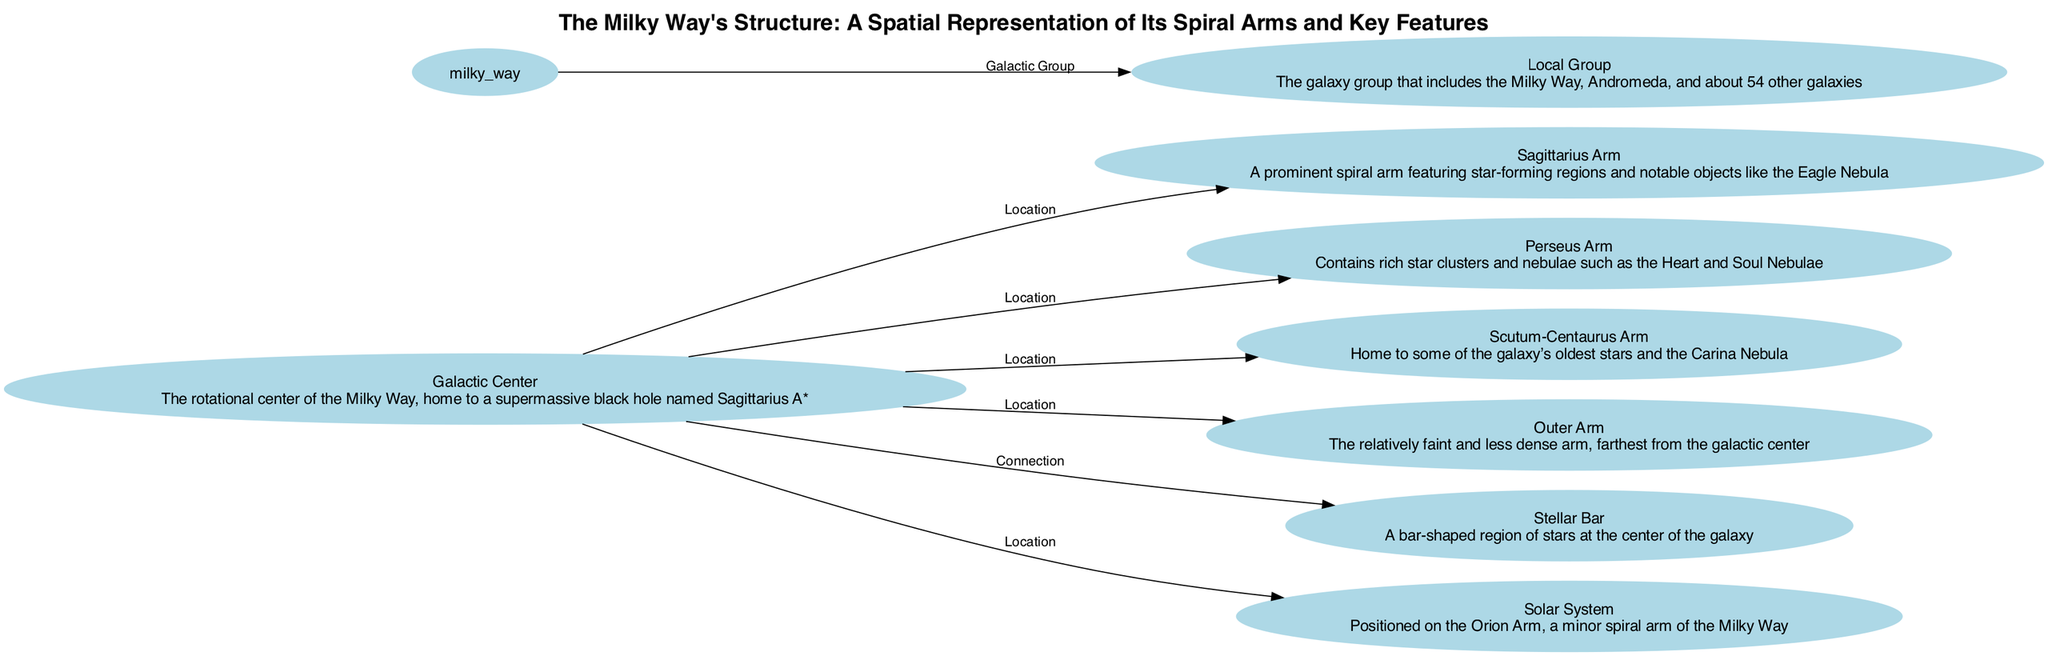What is located at the center of the Milky Way? The diagram shows the "Galactic Center" as the central node, identified clearly in the diagram.
Answer: Galactic Center How many spiral arms are depicted in the diagram? Counting the nodes labeled as spiral arms: Sagittarius Arm, Perseus Arm, Scutum-Centaurus Arm, and Outer Arm, there are four such nodes shown.
Answer: Four Which arm is associated with the Carina Nebula? The Scutum-Centaurus Arm node in the diagram specifies that it is home to the Carina Nebula, providing the necessary information to answer the question directly.
Answer: Scutum-Centaurus Arm What feature connects the Galactic Center to the Sagittarius Arm? The diagram indicates a direct connection labeled "Location" from the Galactic Center to the Sagittarius Arm, defining their spatial relationship clearly.
Answer: Location Is the Solar System located on a spiral arm? The diagram specifies that the Solar System is positioned on the Orion Arm, which is mentioned as a minor spiral arm of the Milky Way.
Answer: Yes What is the relationship between the Milky Way and the Local Group? The edge in the diagram labeled "Galactic Group" indicates a direct relationship between the Milky Way and the Local Group, which includes other galaxies.
Answer: Galactic Group Which arm contains rich star clusters such as the Heart and Soul Nebulae? The Perseus Arm node describes its features, including the presence of rich star clusters and nebulae like the Heart and Soul Nebulae, giving a clear answer to the question.
Answer: Perseus Arm What is the main feature at the Galactic Center? The description under the Galactic Center node states it is home to a supermassive black hole named Sagittarius A*, which defines the significant characteristic of that location.
Answer: Supermassive black hole Which arm is the furthest from the Galactic Center? The Outer Arm is specified in the diagram as the relatively faint and less dense arm, indicating its position as the furthest from the galactic center.
Answer: Outer Arm 